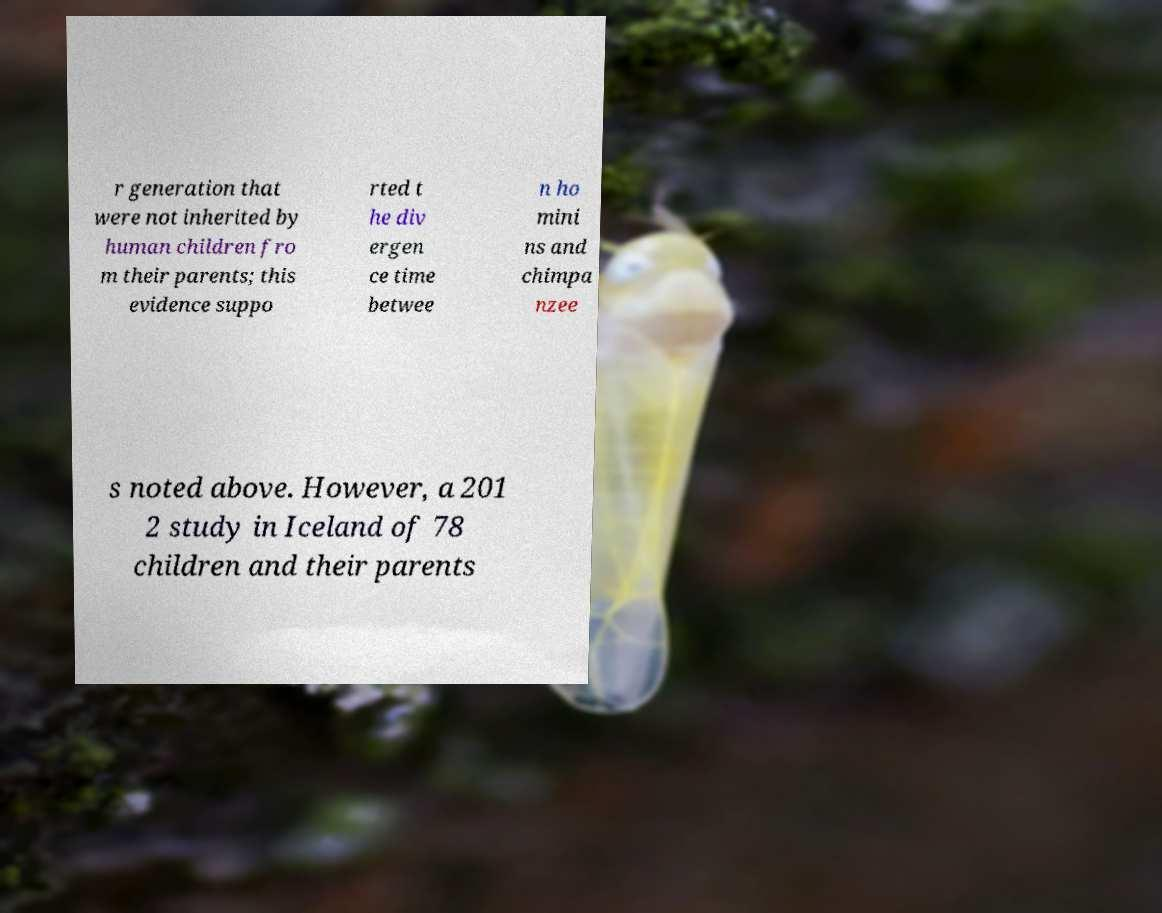There's text embedded in this image that I need extracted. Can you transcribe it verbatim? r generation that were not inherited by human children fro m their parents; this evidence suppo rted t he div ergen ce time betwee n ho mini ns and chimpa nzee s noted above. However, a 201 2 study in Iceland of 78 children and their parents 